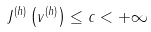<formula> <loc_0><loc_0><loc_500><loc_500>J ^ { ( h ) } \left ( v ^ { ( h ) } \right ) \leq c < + \infty</formula> 